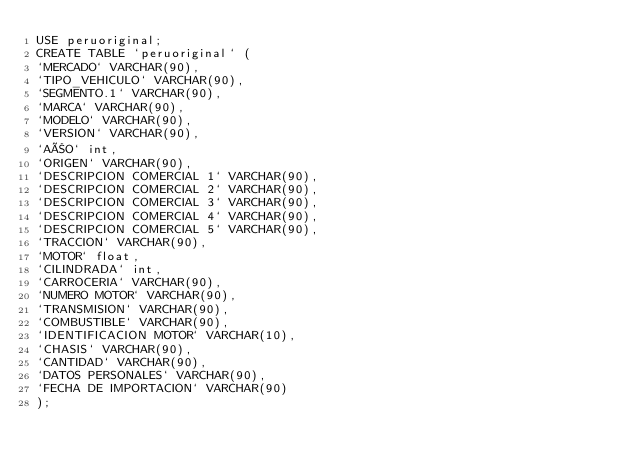<code> <loc_0><loc_0><loc_500><loc_500><_SQL_>USE peruoriginal;
CREATE TABLE `peruoriginal` (
`MERCADO` VARCHAR(90),
`TIPO_VEHICULO` VARCHAR(90),
`SEGMENTO.1` VARCHAR(90),
`MARCA` VARCHAR(90),
`MODELO` VARCHAR(90),
`VERSION` VARCHAR(90),
`AÑO` int,
`ORIGEN` VARCHAR(90),
`DESCRIPCION COMERCIAL 1` VARCHAR(90),
`DESCRIPCION COMERCIAL 2` VARCHAR(90),
`DESCRIPCION COMERCIAL 3` VARCHAR(90),
`DESCRIPCION COMERCIAL 4` VARCHAR(90),
`DESCRIPCION COMERCIAL 5` VARCHAR(90),
`TRACCION` VARCHAR(90),
`MOTOR` float,
`CILINDRADA` int,
`CARROCERIA` VARCHAR(90),
`NUMERO MOTOR` VARCHAR(90),
`TRANSMISION` VARCHAR(90),
`COMBUSTIBLE` VARCHAR(90),
`IDENTIFICACION MOTOR` VARCHAR(10),
`CHASIS` VARCHAR(90),
`CANTIDAD` VARCHAR(90),
`DATOS PERSONALES` VARCHAR(90),
`FECHA DE IMPORTACION` VARCHAR(90)
);
</code> 